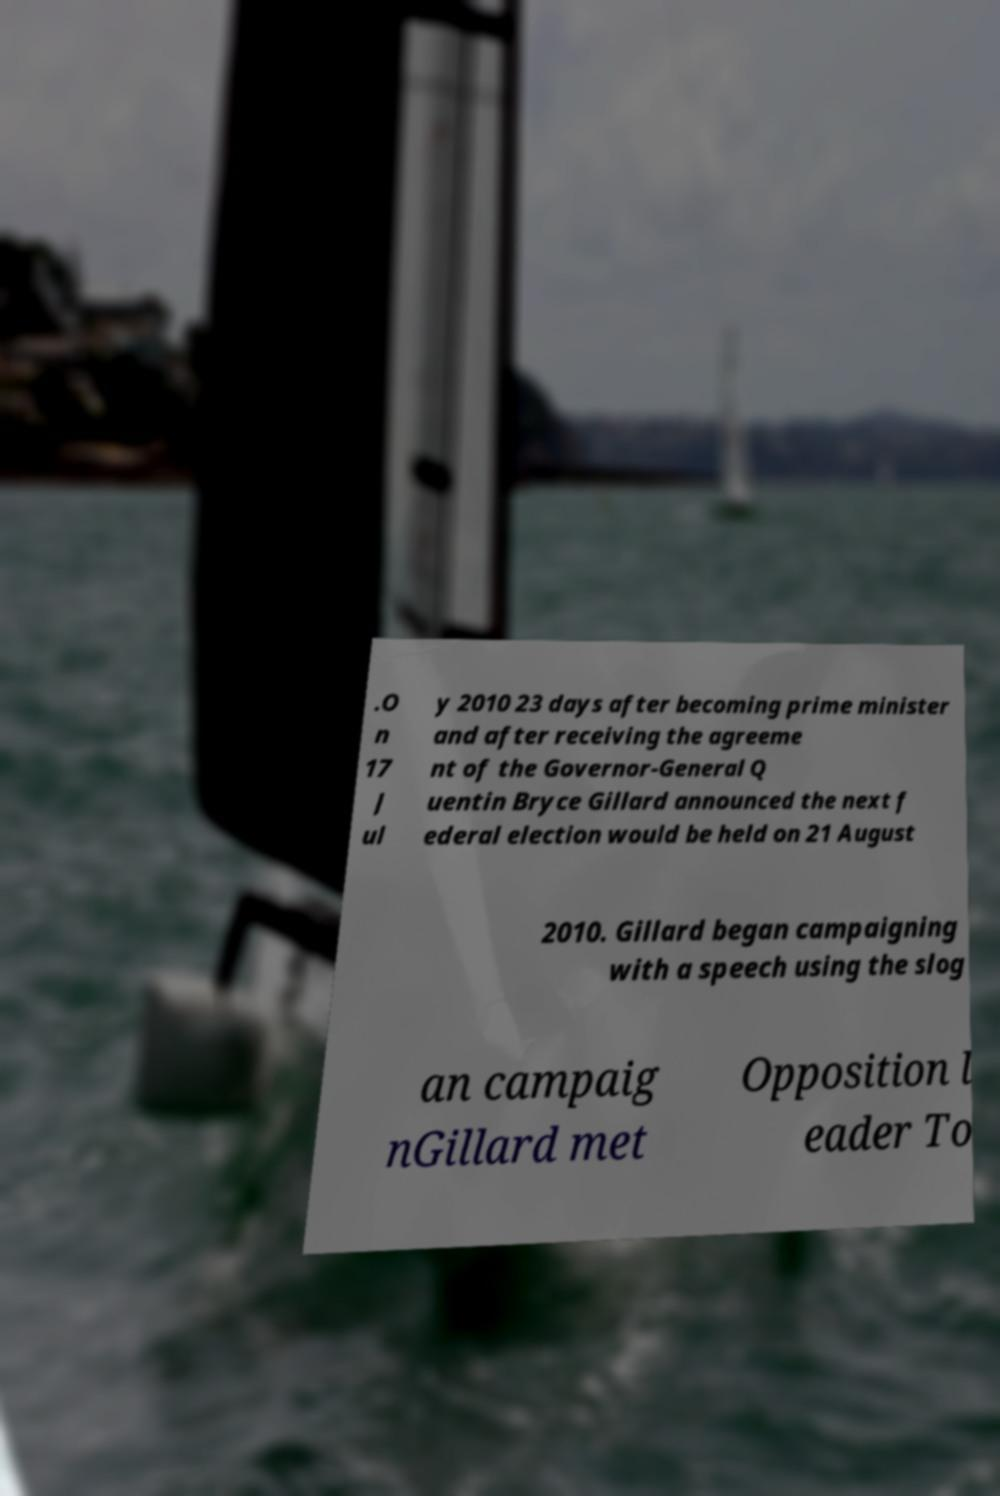For documentation purposes, I need the text within this image transcribed. Could you provide that? .O n 17 J ul y 2010 23 days after becoming prime minister and after receiving the agreeme nt of the Governor-General Q uentin Bryce Gillard announced the next f ederal election would be held on 21 August 2010. Gillard began campaigning with a speech using the slog an campaig nGillard met Opposition l eader To 